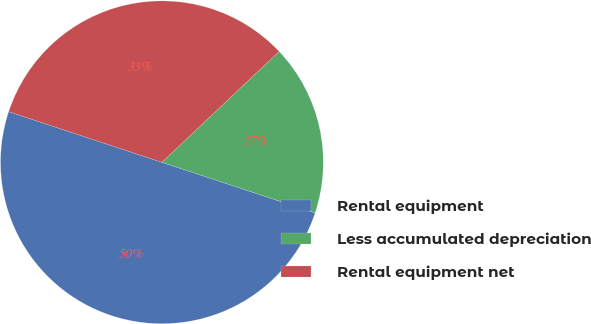<chart> <loc_0><loc_0><loc_500><loc_500><pie_chart><fcel>Rental equipment<fcel>Less accumulated depreciation<fcel>Rental equipment net<nl><fcel>50.0%<fcel>17.13%<fcel>32.87%<nl></chart> 